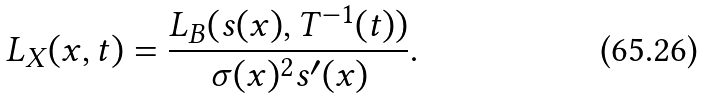<formula> <loc_0><loc_0><loc_500><loc_500>L _ { X } ( x , t ) = \frac { L _ { B } ( s ( x ) , T ^ { - 1 } ( t ) ) } { \sigma ( x ) ^ { 2 } s ^ { \prime } ( x ) } .</formula> 